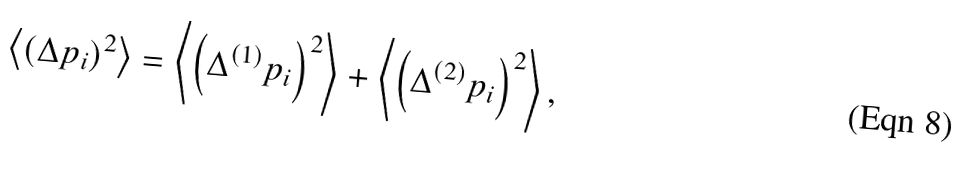Convert formula to latex. <formula><loc_0><loc_0><loc_500><loc_500>\left \langle \left ( \Delta p _ { i } \right ) ^ { 2 } \right \rangle = \left \langle \left ( \Delta ^ { ( 1 ) } p _ { i } \right ) ^ { 2 } \right \rangle + \left \langle \left ( \Delta ^ { ( 2 ) } p _ { i } \right ) ^ { 2 } \right \rangle ,</formula> 